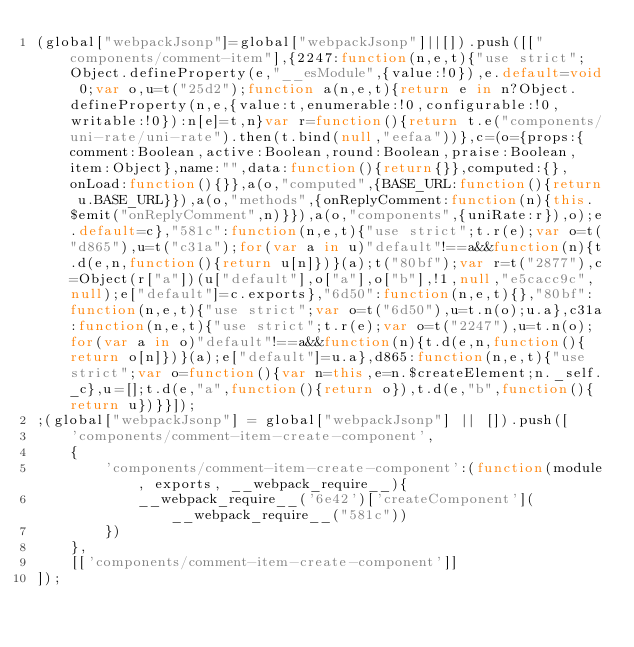<code> <loc_0><loc_0><loc_500><loc_500><_JavaScript_>(global["webpackJsonp"]=global["webpackJsonp"]||[]).push([["components/comment-item"],{2247:function(n,e,t){"use strict";Object.defineProperty(e,"__esModule",{value:!0}),e.default=void 0;var o,u=t("25d2");function a(n,e,t){return e in n?Object.defineProperty(n,e,{value:t,enumerable:!0,configurable:!0,writable:!0}):n[e]=t,n}var r=function(){return t.e("components/uni-rate/uni-rate").then(t.bind(null,"eefaa"))},c=(o={props:{comment:Boolean,active:Boolean,round:Boolean,praise:Boolean,item:Object},name:"",data:function(){return{}},computed:{},onLoad:function(){}},a(o,"computed",{BASE_URL:function(){return u.BASE_URL}}),a(o,"methods",{onReplyComment:function(n){this.$emit("onReplyComment",n)}}),a(o,"components",{uniRate:r}),o);e.default=c},"581c":function(n,e,t){"use strict";t.r(e);var o=t("d865"),u=t("c31a");for(var a in u)"default"!==a&&function(n){t.d(e,n,function(){return u[n]})}(a);t("80bf");var r=t("2877"),c=Object(r["a"])(u["default"],o["a"],o["b"],!1,null,"e5cacc9c",null);e["default"]=c.exports},"6d50":function(n,e,t){},"80bf":function(n,e,t){"use strict";var o=t("6d50"),u=t.n(o);u.a},c31a:function(n,e,t){"use strict";t.r(e);var o=t("2247"),u=t.n(o);for(var a in o)"default"!==a&&function(n){t.d(e,n,function(){return o[n]})}(a);e["default"]=u.a},d865:function(n,e,t){"use strict";var o=function(){var n=this,e=n.$createElement;n._self._c},u=[];t.d(e,"a",function(){return o}),t.d(e,"b",function(){return u})}}]);
;(global["webpackJsonp"] = global["webpackJsonp"] || []).push([
    'components/comment-item-create-component',
    {
        'components/comment-item-create-component':(function(module, exports, __webpack_require__){
            __webpack_require__('6e42')['createComponent'](__webpack_require__("581c"))
        })
    },
    [['components/comment-item-create-component']]
]);                
</code> 